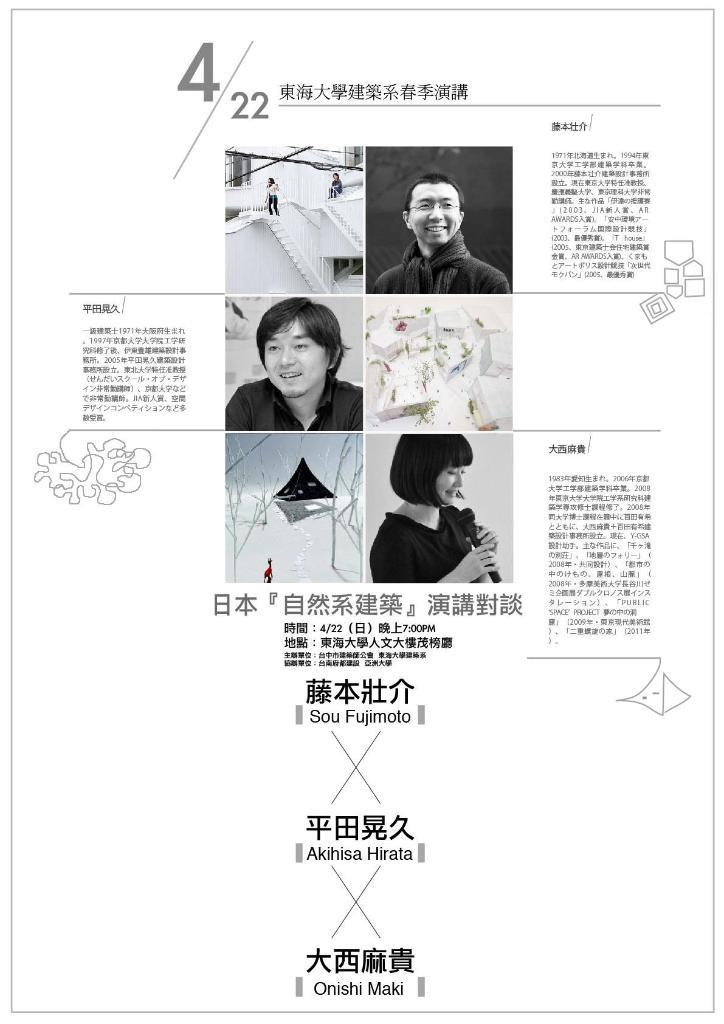What is present on the poster in the image? The poster contains images and written matter. What color scheme is used for the poster? The poster is in black and white. What type of silver design can be seen on the poster? There is no silver design present on the poster; it is in black and white. 